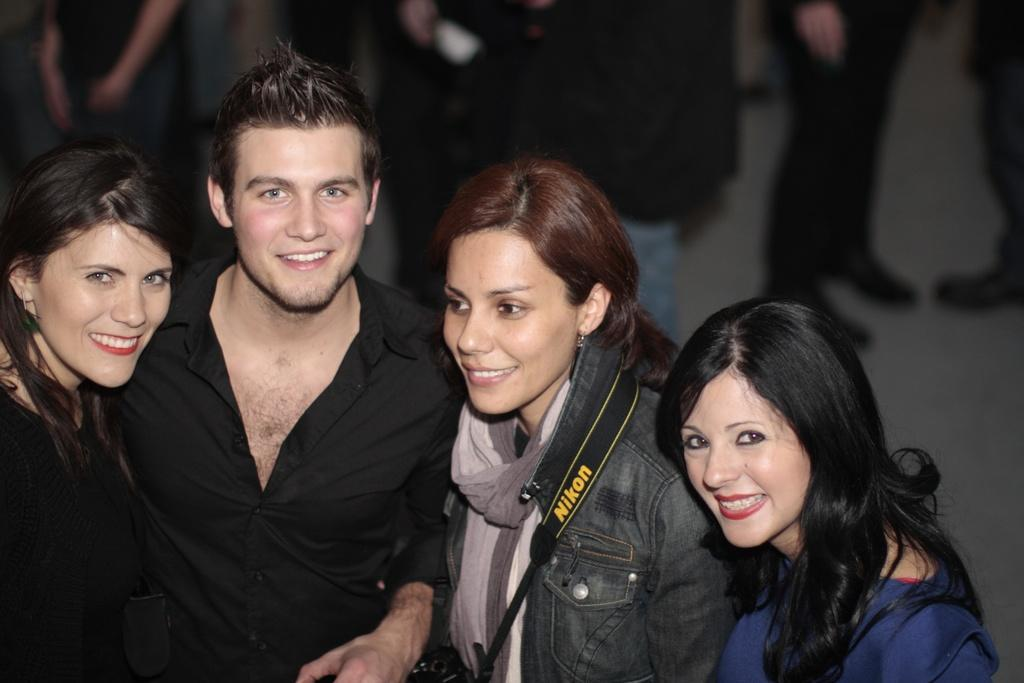What is happening in the image? There are people standing in the image. Where are the people standing? The people are standing on the floor. Can you describe the background of the image? The background of the image is blurred. What type of sticks are being used by the people in the image? There are no sticks visible in the image. How much sugar is being consumed by the people in the image? There is no indication of sugar consumption in the image. 